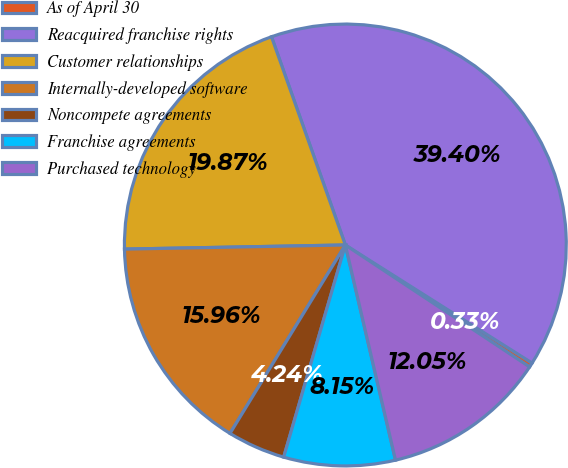<chart> <loc_0><loc_0><loc_500><loc_500><pie_chart><fcel>As of April 30<fcel>Reacquired franchise rights<fcel>Customer relationships<fcel>Internally-developed software<fcel>Noncompete agreements<fcel>Franchise agreements<fcel>Purchased technology<nl><fcel>0.33%<fcel>39.4%<fcel>19.87%<fcel>15.96%<fcel>4.24%<fcel>8.15%<fcel>12.05%<nl></chart> 